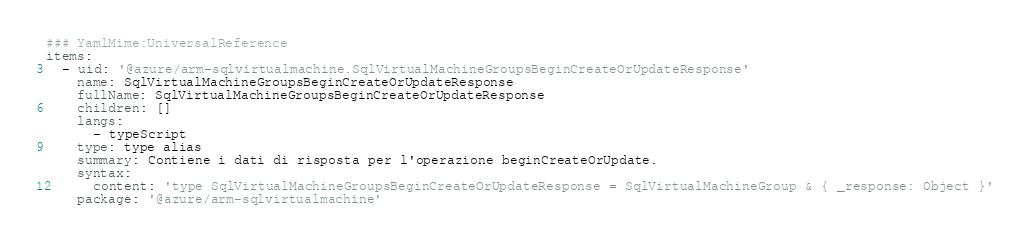<code> <loc_0><loc_0><loc_500><loc_500><_YAML_>### YamlMime:UniversalReference
items:
  - uid: '@azure/arm-sqlvirtualmachine.SqlVirtualMachineGroupsBeginCreateOrUpdateResponse'
    name: SqlVirtualMachineGroupsBeginCreateOrUpdateResponse
    fullName: SqlVirtualMachineGroupsBeginCreateOrUpdateResponse
    children: []
    langs:
      - typeScript
    type: type alias
    summary: Contiene i dati di risposta per l'operazione beginCreateOrUpdate.
    syntax:
      content: 'type SqlVirtualMachineGroupsBeginCreateOrUpdateResponse = SqlVirtualMachineGroup & { _response: Object }'
    package: '@azure/arm-sqlvirtualmachine'</code> 